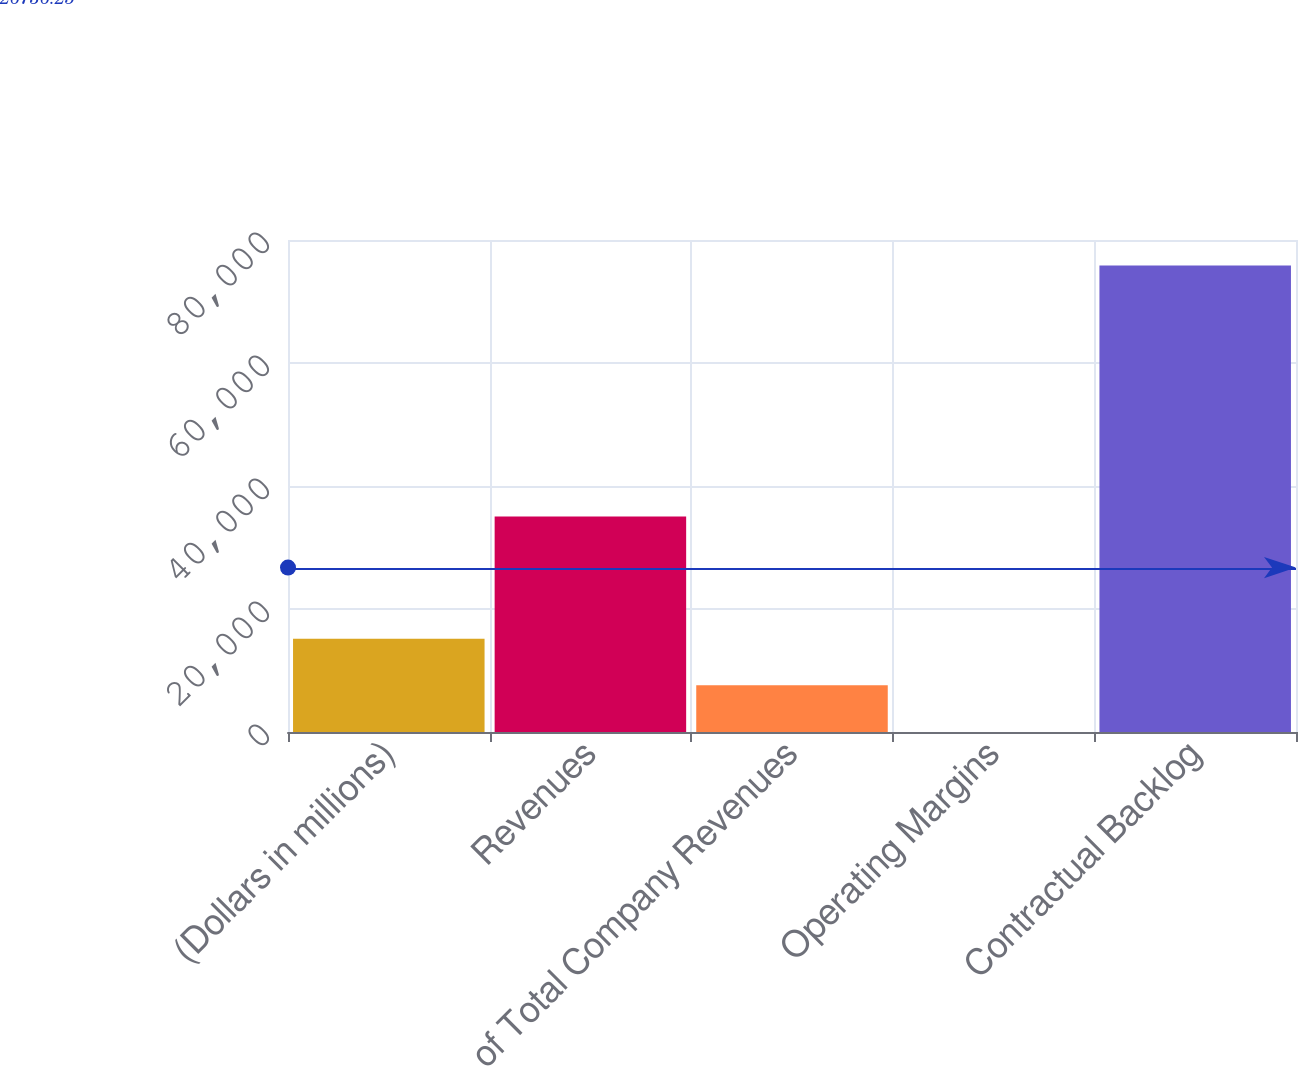<chart> <loc_0><loc_0><loc_500><loc_500><bar_chart><fcel>(Dollars in millions)<fcel>Revenues<fcel>of Total Company Revenues<fcel>Operating Margins<fcel>Contractual Backlog<nl><fcel>15176<fcel>35056<fcel>7591.75<fcel>7.5<fcel>75850<nl></chart> 